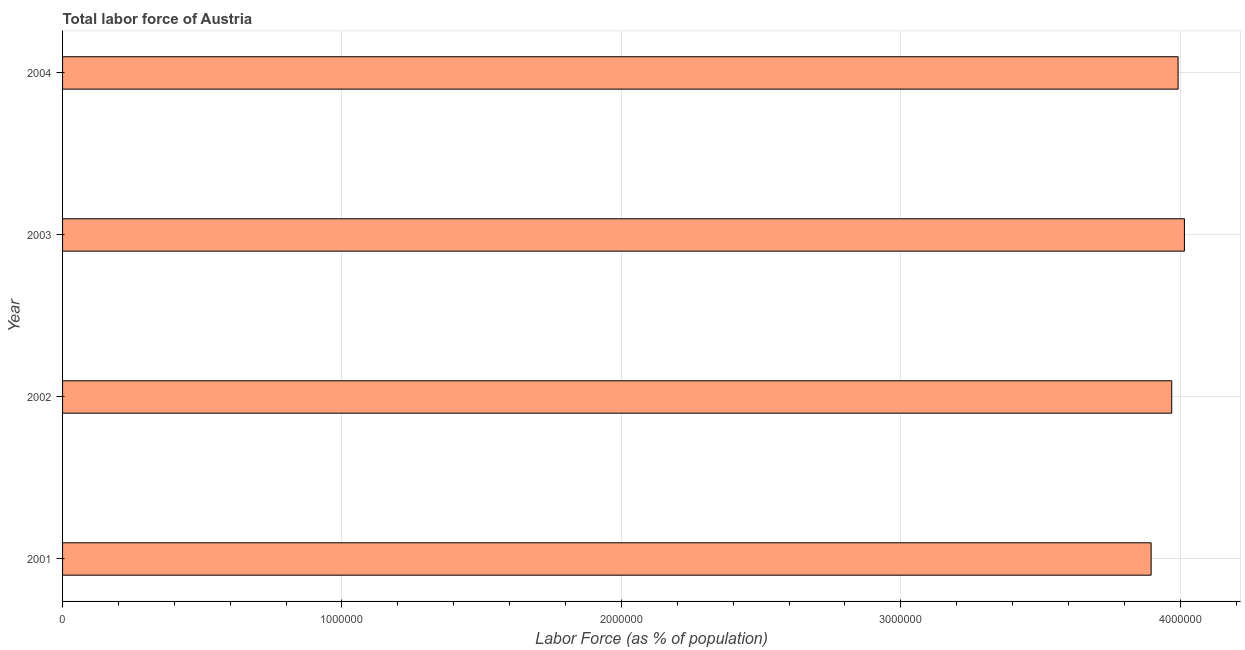Does the graph contain any zero values?
Keep it short and to the point. No. Does the graph contain grids?
Your response must be concise. Yes. What is the title of the graph?
Offer a terse response. Total labor force of Austria. What is the label or title of the X-axis?
Your response must be concise. Labor Force (as % of population). What is the total labor force in 2003?
Give a very brief answer. 4.02e+06. Across all years, what is the maximum total labor force?
Provide a short and direct response. 4.02e+06. Across all years, what is the minimum total labor force?
Offer a very short reply. 3.90e+06. What is the sum of the total labor force?
Offer a very short reply. 1.59e+07. What is the difference between the total labor force in 2001 and 2004?
Keep it short and to the point. -9.65e+04. What is the average total labor force per year?
Ensure brevity in your answer.  3.97e+06. What is the median total labor force?
Offer a terse response. 3.98e+06. In how many years, is the total labor force greater than 2600000 %?
Your answer should be very brief. 4. Do a majority of the years between 2001 and 2004 (inclusive) have total labor force greater than 3400000 %?
Your answer should be very brief. Yes. What is the ratio of the total labor force in 2003 to that in 2004?
Keep it short and to the point. 1.01. What is the difference between the highest and the second highest total labor force?
Your response must be concise. 2.26e+04. What is the difference between the highest and the lowest total labor force?
Give a very brief answer. 1.19e+05. How many bars are there?
Your answer should be very brief. 4. Are all the bars in the graph horizontal?
Your response must be concise. Yes. How many years are there in the graph?
Make the answer very short. 4. Are the values on the major ticks of X-axis written in scientific E-notation?
Provide a succinct answer. No. What is the Labor Force (as % of population) of 2001?
Your answer should be compact. 3.90e+06. What is the Labor Force (as % of population) in 2002?
Your answer should be very brief. 3.97e+06. What is the Labor Force (as % of population) of 2003?
Offer a terse response. 4.02e+06. What is the Labor Force (as % of population) of 2004?
Your response must be concise. 3.99e+06. What is the difference between the Labor Force (as % of population) in 2001 and 2002?
Provide a succinct answer. -7.37e+04. What is the difference between the Labor Force (as % of population) in 2001 and 2003?
Ensure brevity in your answer.  -1.19e+05. What is the difference between the Labor Force (as % of population) in 2001 and 2004?
Your response must be concise. -9.65e+04. What is the difference between the Labor Force (as % of population) in 2002 and 2003?
Offer a very short reply. -4.54e+04. What is the difference between the Labor Force (as % of population) in 2002 and 2004?
Make the answer very short. -2.28e+04. What is the difference between the Labor Force (as % of population) in 2003 and 2004?
Keep it short and to the point. 2.26e+04. What is the ratio of the Labor Force (as % of population) in 2001 to that in 2003?
Offer a very short reply. 0.97. What is the ratio of the Labor Force (as % of population) in 2001 to that in 2004?
Ensure brevity in your answer.  0.98. What is the ratio of the Labor Force (as % of population) in 2002 to that in 2003?
Offer a terse response. 0.99. What is the ratio of the Labor Force (as % of population) in 2003 to that in 2004?
Give a very brief answer. 1.01. 